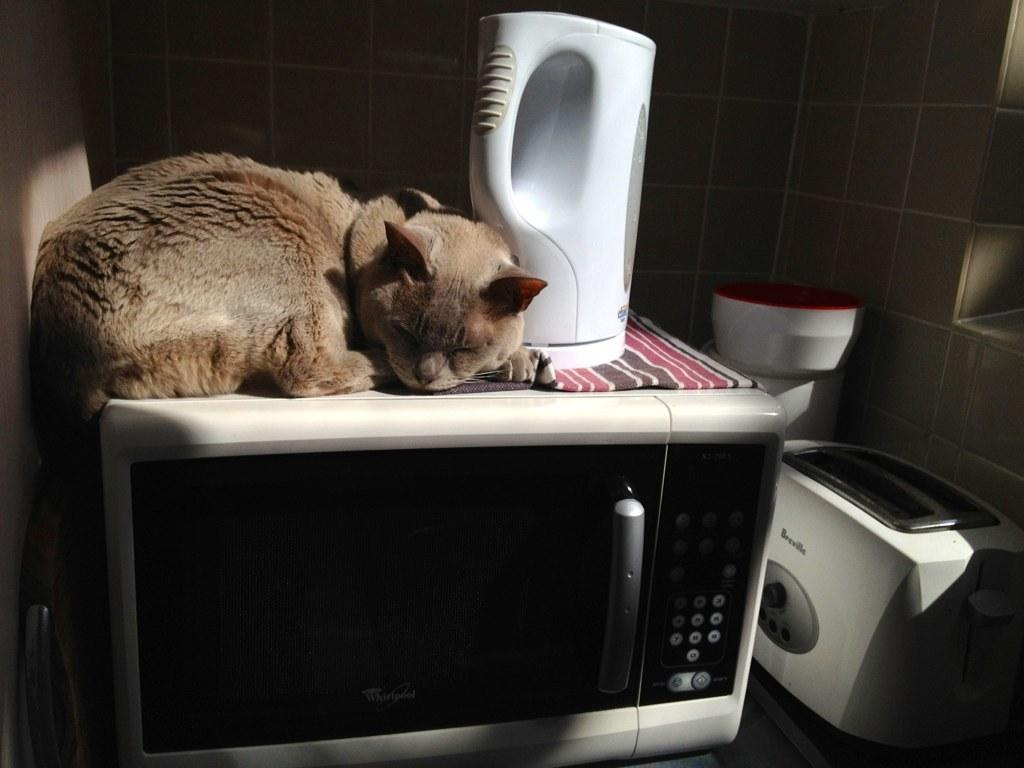What type of animal is in the image? There is a cat in the image. What is the cat doing in the image? The cat is sleeping on a micro oven. What other kitchen appliances are visible in the image? There is a bread toaster in the image. Is there any container for water in the image? Yes, there is a water jug in the image. What type of sheet is covering the country in the image? There is no sheet or country present in the image; it features a cat sleeping on a micro oven and other kitchen appliances. 